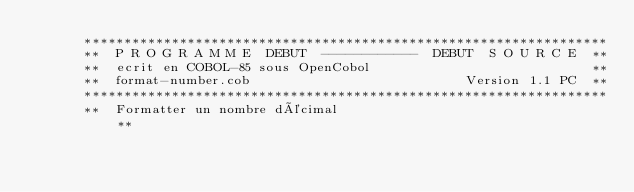Convert code to text. <code><loc_0><loc_0><loc_500><loc_500><_COBOL_>      ******************************************************************
      **  P R O G R A M M E  DEBUT  ------------  DEBUT  S O U R C E  **
      **  ecrit en COBOL-85 sous OpenCobol                            **
      **  format-number.cob                           Version 1.1 PC  **
      ******************************************************************
      **  Formatter un nombre décimal                                 **</code> 